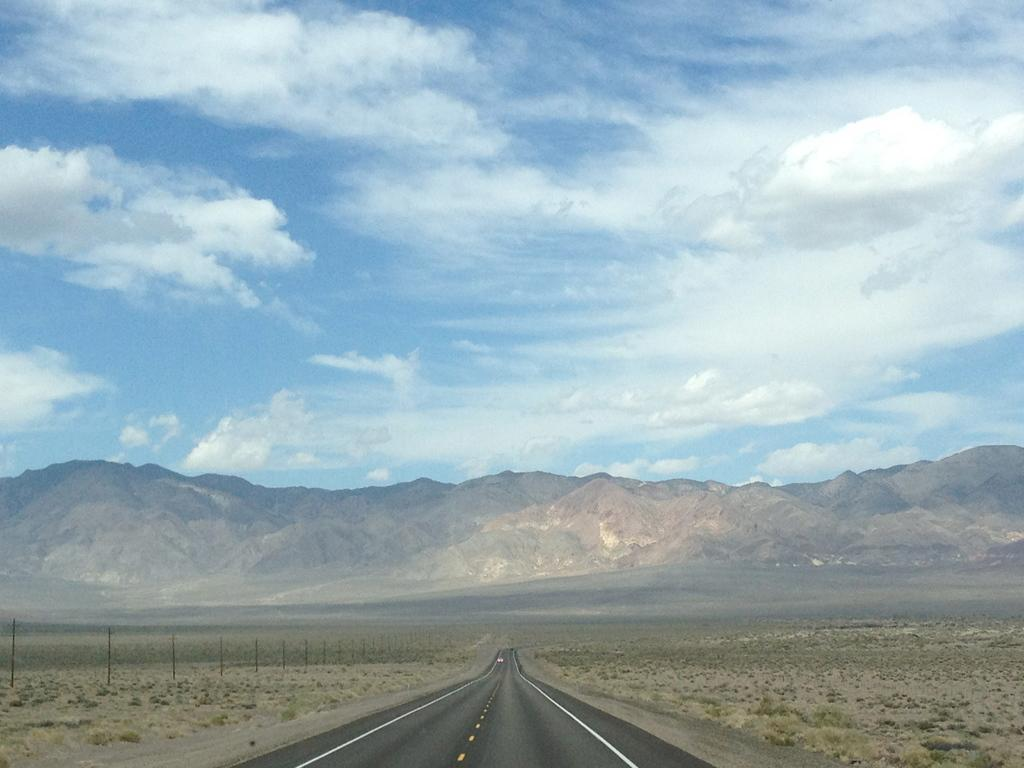What is the main feature in the center of the image? There is a road in the center of the image. What can be seen on the left side of the image? There are poles on the left side of the image. What is visible in the background of the image? There are mountains in the background of the image. How would you describe the sky in the image? The sky is cloudy in the image. What is the name of the crow sitting on the road in the image? There is no crow present in the image. Can you see a playing card lying on the road in the image? There is no playing card visible in the image. 